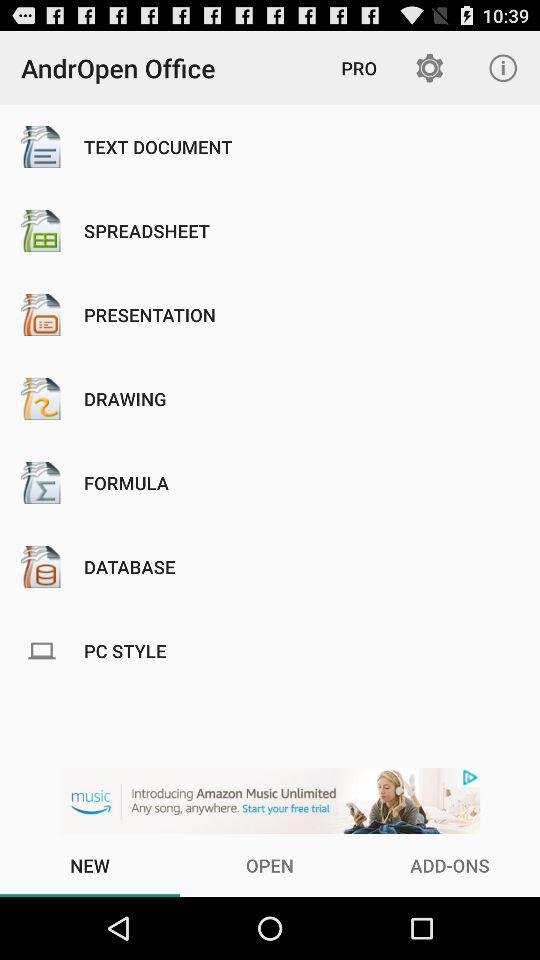Which tab is selected? The selected tab is "NEW". 